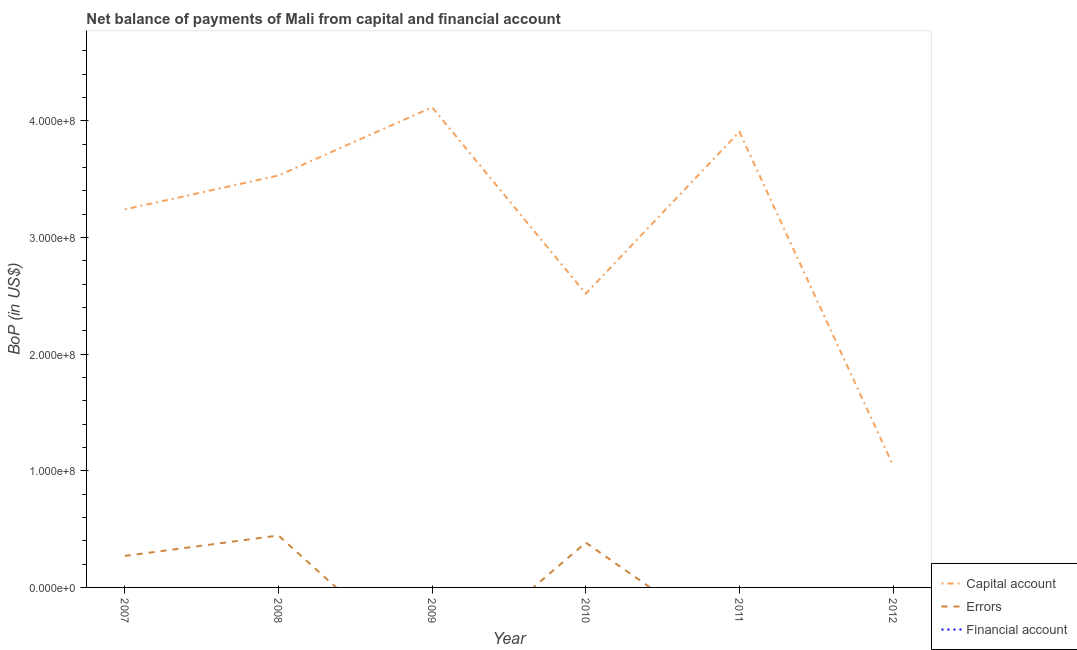Does the line corresponding to amount of errors intersect with the line corresponding to amount of net capital account?
Ensure brevity in your answer.  No. Is the number of lines equal to the number of legend labels?
Make the answer very short. No. What is the amount of net capital account in 2010?
Offer a terse response. 2.52e+08. Across all years, what is the maximum amount of net capital account?
Provide a succinct answer. 4.12e+08. Across all years, what is the minimum amount of net capital account?
Keep it short and to the point. 1.05e+08. What is the total amount of net capital account in the graph?
Your answer should be compact. 1.84e+09. What is the difference between the amount of net capital account in 2007 and that in 2012?
Your answer should be compact. 2.20e+08. What is the average amount of net capital account per year?
Make the answer very short. 3.06e+08. In the year 2008, what is the difference between the amount of net capital account and amount of errors?
Make the answer very short. 3.09e+08. What is the ratio of the amount of net capital account in 2007 to that in 2008?
Give a very brief answer. 0.92. Is the amount of errors in 2007 less than that in 2010?
Offer a very short reply. Yes. What is the difference between the highest and the second highest amount of errors?
Give a very brief answer. 6.10e+06. What is the difference between the highest and the lowest amount of errors?
Your answer should be very brief. 4.45e+07. In how many years, is the amount of financial account greater than the average amount of financial account taken over all years?
Provide a succinct answer. 0. Is the sum of the amount of net capital account in 2008 and 2010 greater than the maximum amount of financial account across all years?
Make the answer very short. Yes. Is the amount of net capital account strictly greater than the amount of errors over the years?
Provide a short and direct response. Yes. How many years are there in the graph?
Your answer should be compact. 6. What is the difference between two consecutive major ticks on the Y-axis?
Your answer should be very brief. 1.00e+08. Where does the legend appear in the graph?
Provide a short and direct response. Bottom right. How many legend labels are there?
Give a very brief answer. 3. How are the legend labels stacked?
Make the answer very short. Vertical. What is the title of the graph?
Provide a short and direct response. Net balance of payments of Mali from capital and financial account. Does "Secondary" appear as one of the legend labels in the graph?
Your answer should be compact. No. What is the label or title of the Y-axis?
Your answer should be compact. BoP (in US$). What is the BoP (in US$) of Capital account in 2007?
Your answer should be compact. 3.24e+08. What is the BoP (in US$) of Errors in 2007?
Your response must be concise. 2.70e+07. What is the BoP (in US$) in Financial account in 2007?
Provide a succinct answer. 0. What is the BoP (in US$) in Capital account in 2008?
Keep it short and to the point. 3.53e+08. What is the BoP (in US$) of Errors in 2008?
Provide a succinct answer. 4.45e+07. What is the BoP (in US$) in Capital account in 2009?
Your answer should be very brief. 4.12e+08. What is the BoP (in US$) of Financial account in 2009?
Your response must be concise. 0. What is the BoP (in US$) in Capital account in 2010?
Offer a very short reply. 2.52e+08. What is the BoP (in US$) of Errors in 2010?
Ensure brevity in your answer.  3.84e+07. What is the BoP (in US$) of Financial account in 2010?
Offer a terse response. 0. What is the BoP (in US$) of Capital account in 2011?
Your answer should be very brief. 3.91e+08. What is the BoP (in US$) of Financial account in 2011?
Your answer should be very brief. 0. What is the BoP (in US$) of Capital account in 2012?
Provide a succinct answer. 1.05e+08. Across all years, what is the maximum BoP (in US$) in Capital account?
Give a very brief answer. 4.12e+08. Across all years, what is the maximum BoP (in US$) of Errors?
Ensure brevity in your answer.  4.45e+07. Across all years, what is the minimum BoP (in US$) of Capital account?
Your answer should be compact. 1.05e+08. What is the total BoP (in US$) of Capital account in the graph?
Keep it short and to the point. 1.84e+09. What is the total BoP (in US$) of Errors in the graph?
Give a very brief answer. 1.10e+08. What is the total BoP (in US$) of Financial account in the graph?
Your answer should be very brief. 0. What is the difference between the BoP (in US$) in Capital account in 2007 and that in 2008?
Provide a short and direct response. -2.91e+07. What is the difference between the BoP (in US$) in Errors in 2007 and that in 2008?
Your answer should be compact. -1.75e+07. What is the difference between the BoP (in US$) in Capital account in 2007 and that in 2009?
Offer a very short reply. -8.75e+07. What is the difference between the BoP (in US$) in Capital account in 2007 and that in 2010?
Provide a short and direct response. 7.23e+07. What is the difference between the BoP (in US$) in Errors in 2007 and that in 2010?
Offer a terse response. -1.14e+07. What is the difference between the BoP (in US$) in Capital account in 2007 and that in 2011?
Offer a very short reply. -6.65e+07. What is the difference between the BoP (in US$) in Capital account in 2007 and that in 2012?
Offer a very short reply. 2.20e+08. What is the difference between the BoP (in US$) of Capital account in 2008 and that in 2009?
Your answer should be compact. -5.84e+07. What is the difference between the BoP (in US$) of Capital account in 2008 and that in 2010?
Keep it short and to the point. 1.01e+08. What is the difference between the BoP (in US$) of Errors in 2008 and that in 2010?
Offer a very short reply. 6.10e+06. What is the difference between the BoP (in US$) of Capital account in 2008 and that in 2011?
Make the answer very short. -3.74e+07. What is the difference between the BoP (in US$) in Capital account in 2008 and that in 2012?
Your answer should be very brief. 2.49e+08. What is the difference between the BoP (in US$) in Capital account in 2009 and that in 2010?
Make the answer very short. 1.60e+08. What is the difference between the BoP (in US$) in Capital account in 2009 and that in 2011?
Your answer should be compact. 2.10e+07. What is the difference between the BoP (in US$) in Capital account in 2009 and that in 2012?
Offer a very short reply. 3.07e+08. What is the difference between the BoP (in US$) in Capital account in 2010 and that in 2011?
Provide a short and direct response. -1.39e+08. What is the difference between the BoP (in US$) of Capital account in 2010 and that in 2012?
Make the answer very short. 1.47e+08. What is the difference between the BoP (in US$) of Capital account in 2011 and that in 2012?
Give a very brief answer. 2.86e+08. What is the difference between the BoP (in US$) of Capital account in 2007 and the BoP (in US$) of Errors in 2008?
Provide a succinct answer. 2.80e+08. What is the difference between the BoP (in US$) of Capital account in 2007 and the BoP (in US$) of Errors in 2010?
Make the answer very short. 2.86e+08. What is the difference between the BoP (in US$) in Capital account in 2008 and the BoP (in US$) in Errors in 2010?
Your answer should be very brief. 3.15e+08. What is the difference between the BoP (in US$) of Capital account in 2009 and the BoP (in US$) of Errors in 2010?
Provide a succinct answer. 3.73e+08. What is the average BoP (in US$) in Capital account per year?
Make the answer very short. 3.06e+08. What is the average BoP (in US$) in Errors per year?
Your response must be concise. 1.83e+07. What is the average BoP (in US$) of Financial account per year?
Offer a terse response. 0. In the year 2007, what is the difference between the BoP (in US$) in Capital account and BoP (in US$) in Errors?
Provide a succinct answer. 2.97e+08. In the year 2008, what is the difference between the BoP (in US$) of Capital account and BoP (in US$) of Errors?
Offer a very short reply. 3.09e+08. In the year 2010, what is the difference between the BoP (in US$) of Capital account and BoP (in US$) of Errors?
Keep it short and to the point. 2.13e+08. What is the ratio of the BoP (in US$) of Capital account in 2007 to that in 2008?
Make the answer very short. 0.92. What is the ratio of the BoP (in US$) of Errors in 2007 to that in 2008?
Offer a very short reply. 0.61. What is the ratio of the BoP (in US$) in Capital account in 2007 to that in 2009?
Ensure brevity in your answer.  0.79. What is the ratio of the BoP (in US$) in Capital account in 2007 to that in 2010?
Your answer should be compact. 1.29. What is the ratio of the BoP (in US$) in Errors in 2007 to that in 2010?
Keep it short and to the point. 0.7. What is the ratio of the BoP (in US$) of Capital account in 2007 to that in 2011?
Give a very brief answer. 0.83. What is the ratio of the BoP (in US$) in Capital account in 2007 to that in 2012?
Provide a succinct answer. 3.1. What is the ratio of the BoP (in US$) in Capital account in 2008 to that in 2009?
Offer a very short reply. 0.86. What is the ratio of the BoP (in US$) of Capital account in 2008 to that in 2010?
Ensure brevity in your answer.  1.4. What is the ratio of the BoP (in US$) in Errors in 2008 to that in 2010?
Your answer should be very brief. 1.16. What is the ratio of the BoP (in US$) in Capital account in 2008 to that in 2011?
Your answer should be compact. 0.9. What is the ratio of the BoP (in US$) in Capital account in 2008 to that in 2012?
Your answer should be very brief. 3.38. What is the ratio of the BoP (in US$) in Capital account in 2009 to that in 2010?
Your answer should be very brief. 1.63. What is the ratio of the BoP (in US$) in Capital account in 2009 to that in 2011?
Your response must be concise. 1.05. What is the ratio of the BoP (in US$) of Capital account in 2009 to that in 2012?
Your response must be concise. 3.94. What is the ratio of the BoP (in US$) in Capital account in 2010 to that in 2011?
Your response must be concise. 0.64. What is the ratio of the BoP (in US$) in Capital account in 2010 to that in 2012?
Provide a short and direct response. 2.41. What is the ratio of the BoP (in US$) in Capital account in 2011 to that in 2012?
Offer a terse response. 3.74. What is the difference between the highest and the second highest BoP (in US$) of Capital account?
Keep it short and to the point. 2.10e+07. What is the difference between the highest and the second highest BoP (in US$) of Errors?
Provide a short and direct response. 6.10e+06. What is the difference between the highest and the lowest BoP (in US$) of Capital account?
Your response must be concise. 3.07e+08. What is the difference between the highest and the lowest BoP (in US$) in Errors?
Offer a terse response. 4.45e+07. 